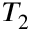<formula> <loc_0><loc_0><loc_500><loc_500>T _ { 2 }</formula> 